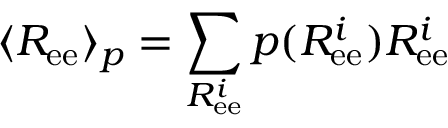<formula> <loc_0><loc_0><loc_500><loc_500>\langle R _ { e e } \rangle _ { p } = \sum _ { R _ { e e } ^ { i } } p ( R _ { e e } ^ { i } ) R _ { e e } ^ { i }</formula> 